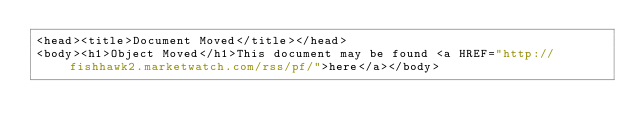<code> <loc_0><loc_0><loc_500><loc_500><_XML_><head><title>Document Moved</title></head>
<body><h1>Object Moved</h1>This document may be found <a HREF="http://fishhawk2.marketwatch.com/rss/pf/">here</a></body></code> 